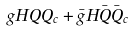<formula> <loc_0><loc_0><loc_500><loc_500>g H Q Q _ { c } + \bar { g } H \bar { Q } \bar { Q } _ { c }</formula> 